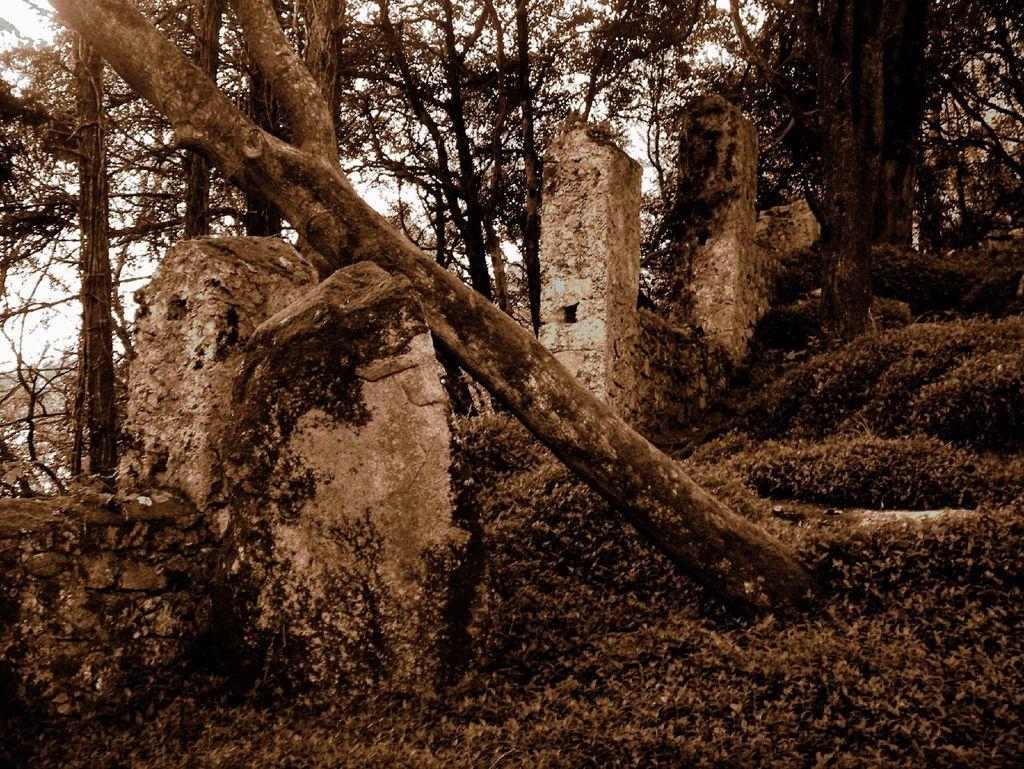Can you describe this image briefly? In this picture I can see few stones and number of trees and I see the white color background. 